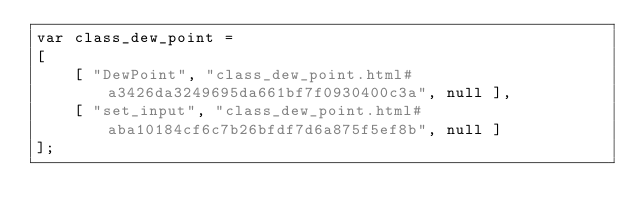<code> <loc_0><loc_0><loc_500><loc_500><_JavaScript_>var class_dew_point =
[
    [ "DewPoint", "class_dew_point.html#a3426da3249695da661bf7f0930400c3a", null ],
    [ "set_input", "class_dew_point.html#aba10184cf6c7b26bfdf7d6a875f5ef8b", null ]
];</code> 